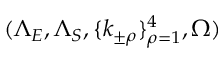<formula> <loc_0><loc_0><loc_500><loc_500>( \Lambda _ { E } , \Lambda _ { S } , \{ k _ { \pm \rho } \} _ { \rho = 1 } ^ { 4 } , \Omega )</formula> 